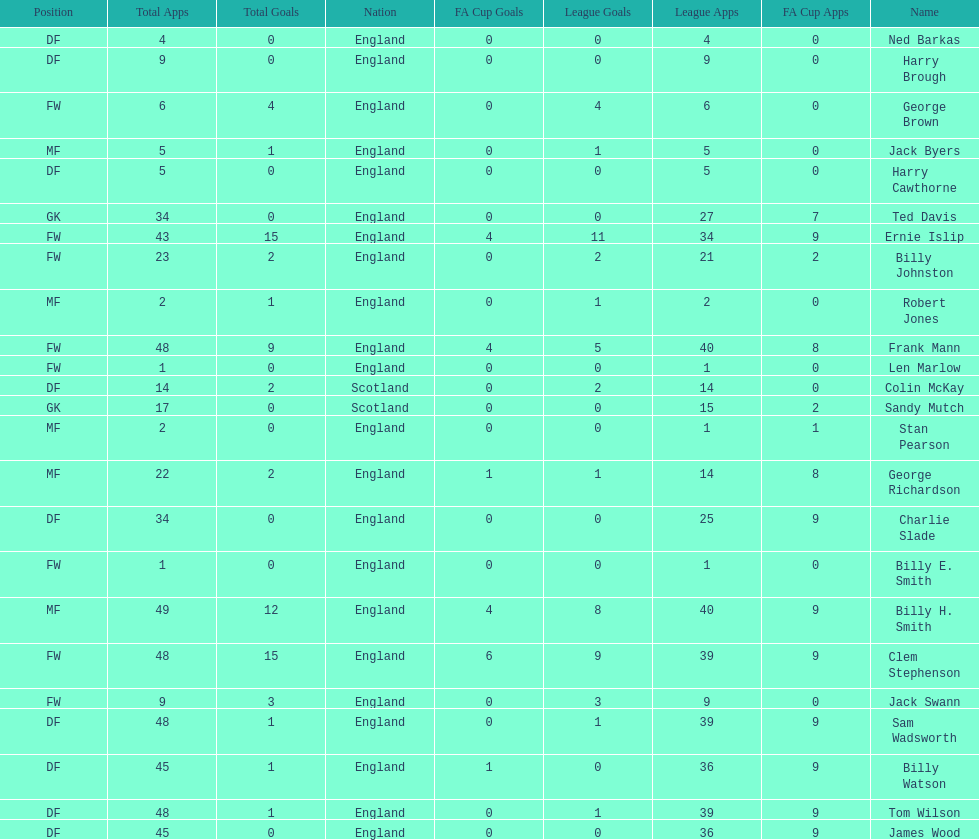The least number of total appearances 1. 